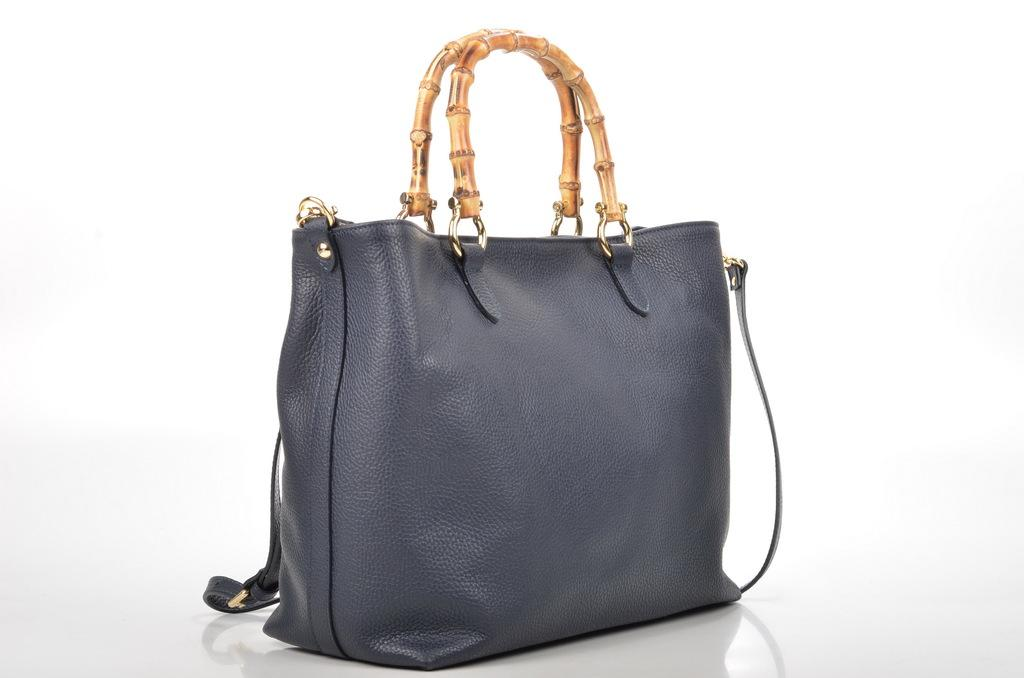What object can be seen in the image? There is a bag in the image. What is the color of the bag? The bag is in light black color. Is there any beef being cooked in the image? There is no beef or any cooking activity present in the image; it only features a bag in light black color. 